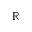Convert formula to latex. <formula><loc_0><loc_0><loc_500><loc_500>\mathbb { R }</formula> 